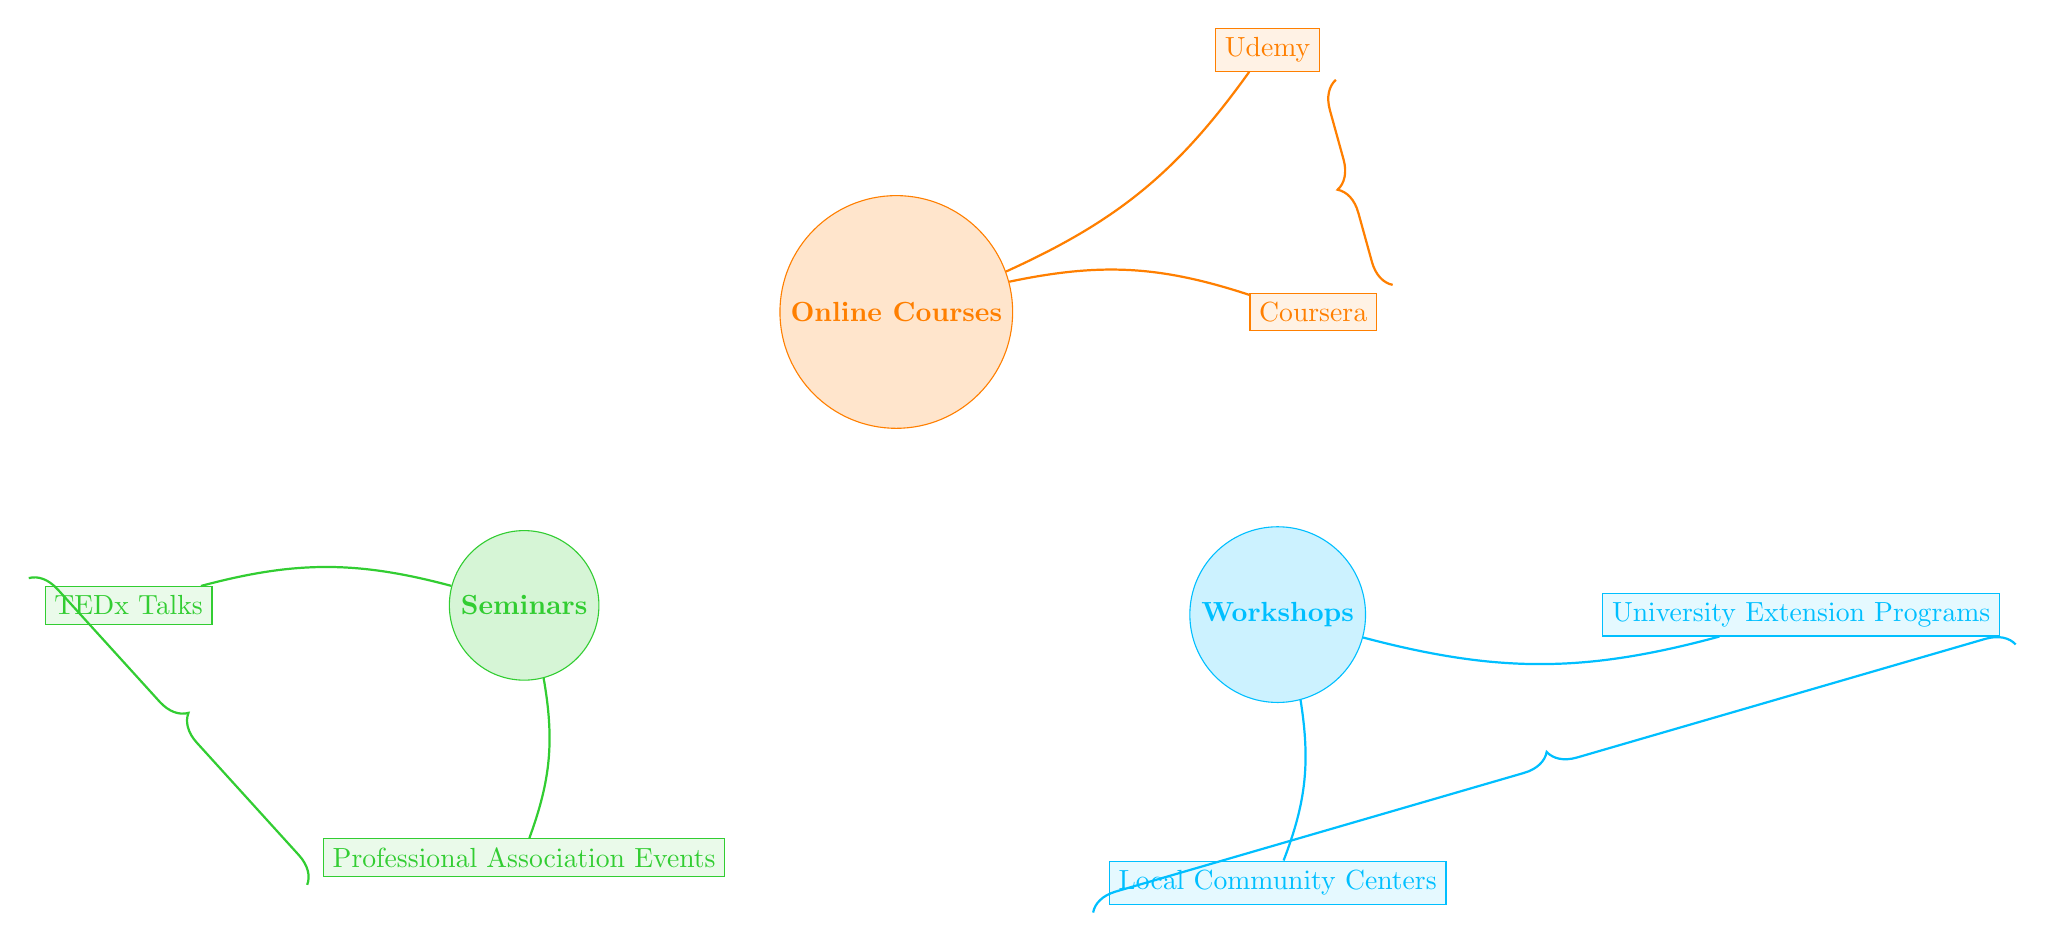What are the three main categories of skill development options for retirees shown in the diagram? The diagram clearly labels three main categories: Online Courses, Workshops, and Seminars. These are the primary nodes identified in the diagram.
Answer: Online Courses, Workshops, Seminars How many online course platforms are linked in the diagram? The diagram shows two online course platforms connected to the Online Courses category: Coursera and Udemy. This can be counted directly from the links emanating from the Online Courses node.
Answer: 2 Which subcategory is connected to Workshops? According to the links originating from the Workshops node, both Local Community Centers and University Extension Programs are connected, but only one is needed. Since it does not specify which one, you could identify either.
Answer: Local Community Centers or University Extension Programs What type of events are related to Seminars? The connections from the Seminars node point to TEDx Talks and Professional Association Events. These are the only types of events associated with Seminars as per the diagram.
Answer: TEDx Talks, Professional Association Events Which online learning platform links to the Workshops category? The diagram indicates that there are no direct links from the Workshops category to online learning platforms. The only links from Workshops are to Local Community Centers and University Extension Programs, which are not platforms. Thus, there’s none.
Answer: None How many connections are there in total in the diagram? By adding up the links shown: there are 2 links from Online Courses, 2 from Workshops, and 2 from Seminars, giving a total of 6 connections in the diagram.
Answer: 6 Which links are dedicated to the Online Courses category? The connections from Online Courses specifically link to Coursera and Udemy. We can see these are the direct subcategories connected to Online Courses from the diagram's edges.
Answer: Coursera, Udemy Is there a direct connection between Workshops and Online Courses? A review of the diagram shows that there are no direct links that connect Workshops to Online Courses, as they are two distinct categories with separate subcategories.
Answer: No 